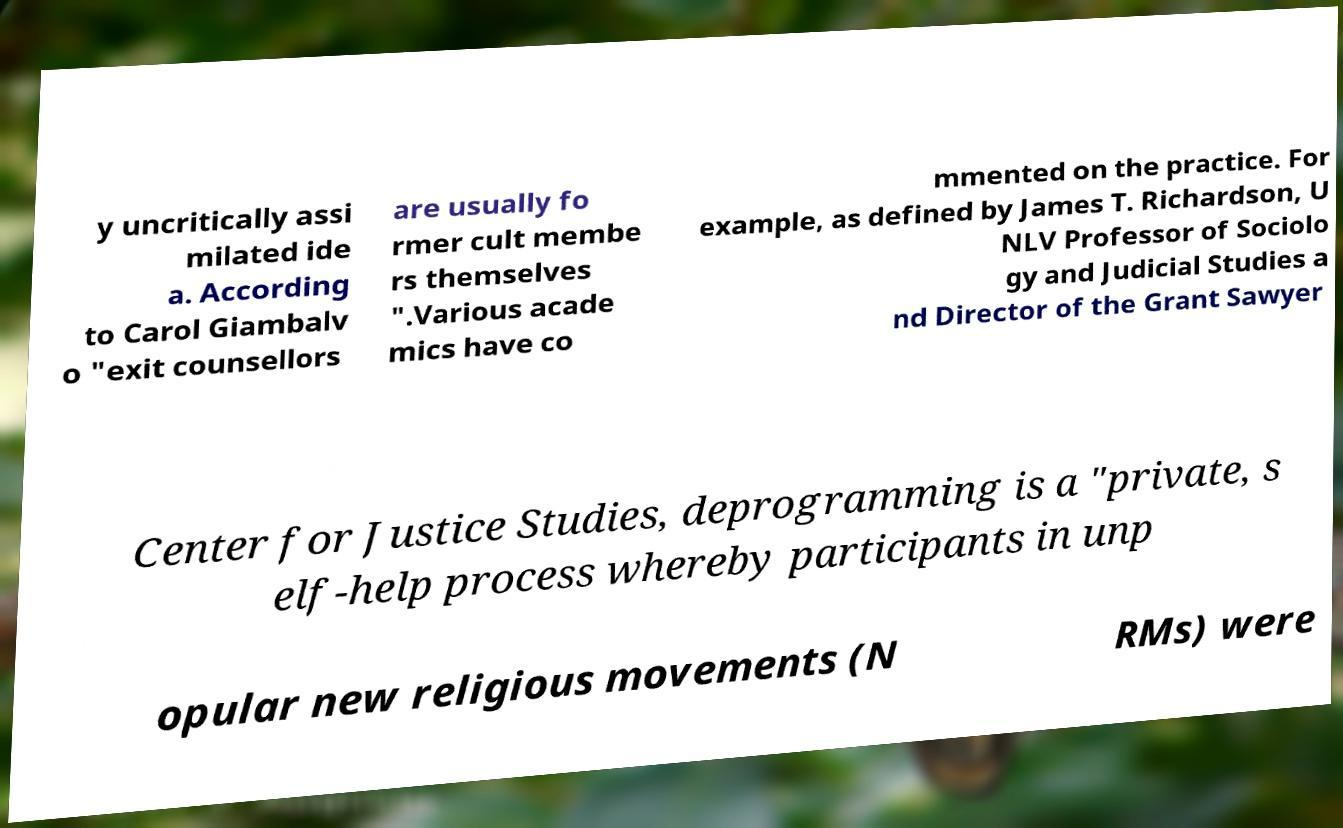I need the written content from this picture converted into text. Can you do that? y uncritically assi milated ide a. According to Carol Giambalv o "exit counsellors are usually fo rmer cult membe rs themselves ".Various acade mics have co mmented on the practice. For example, as defined by James T. Richardson, U NLV Professor of Sociolo gy and Judicial Studies a nd Director of the Grant Sawyer Center for Justice Studies, deprogramming is a "private, s elf-help process whereby participants in unp opular new religious movements (N RMs) were 